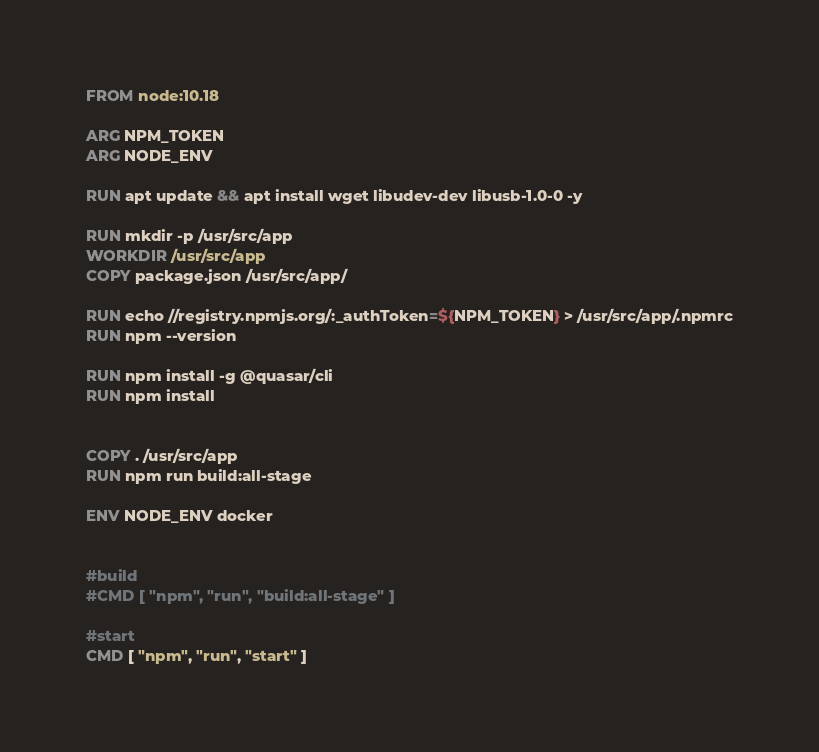Convert code to text. <code><loc_0><loc_0><loc_500><loc_500><_Dockerfile_>FROM node:10.18

ARG NPM_TOKEN
ARG NODE_ENV

RUN apt update && apt install wget libudev-dev libusb-1.0-0 -y

RUN mkdir -p /usr/src/app
WORKDIR /usr/src/app
COPY package.json /usr/src/app/

RUN echo //registry.npmjs.org/:_authToken=${NPM_TOKEN} > /usr/src/app/.npmrc
RUN npm --version

RUN npm install -g @quasar/cli
RUN npm install


COPY . /usr/src/app
RUN npm run build:all-stage

ENV NODE_ENV docker


#build
#CMD [ "npm", "run", "build:all-stage" ]

#start
CMD [ "npm", "run", "start" ]</code> 